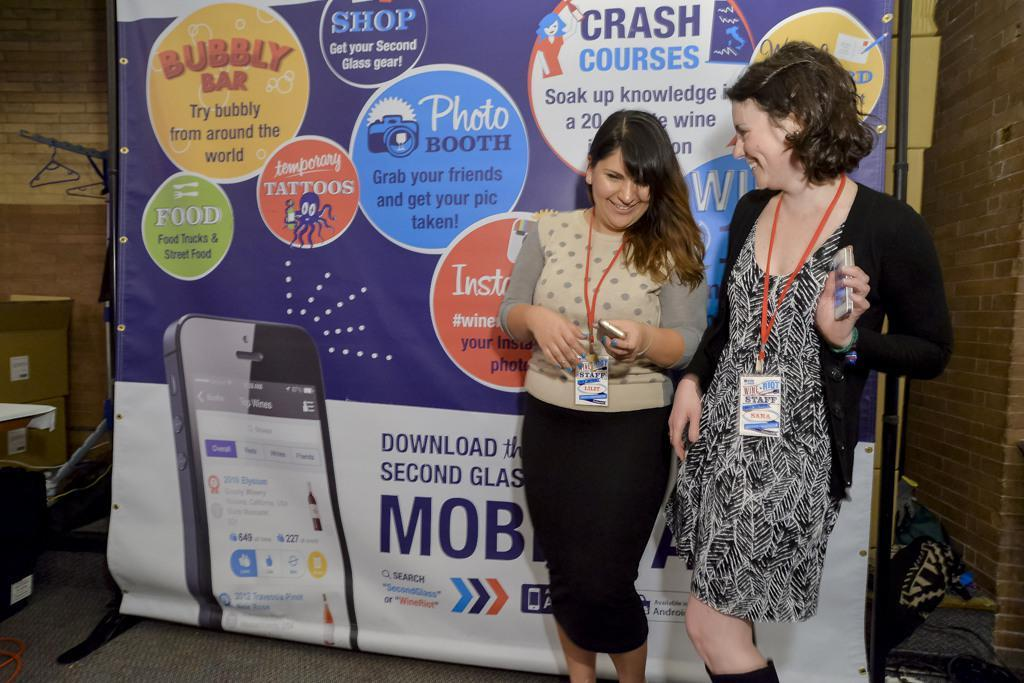How many women are in the image? There are two women in the image. What are the women doing in the image? The women are standing on the floor and smiling. What can be seen hanging in the image? There is a banner in the image. What type of floor covering is visible in the image? The floor is covered with a carpet. What is visible in the background of the image? There is a wall and boxes in the background of the image. What type of popcorn is being served in the image? There is no popcorn present in the image. 